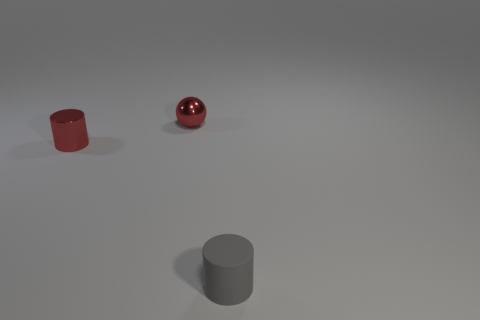Are there any tiny cylinders of the same color as the small sphere?
Offer a very short reply. Yes. What shape is the metallic thing that is the same color as the metal cylinder?
Make the answer very short. Sphere. Is there any other thing that has the same color as the small sphere?
Your answer should be very brief. Yes. What is the material of the small thing that is right of the red shiny cylinder and in front of the tiny red metallic sphere?
Your answer should be very brief. Rubber. How many small cylinders are the same color as the small metallic ball?
Offer a very short reply. 1. There is a tiny metal sphere; is its color the same as the cylinder left of the small rubber cylinder?
Ensure brevity in your answer.  Yes. The other object that is the same shape as the rubber thing is what size?
Your answer should be compact. Small. Are there any other things that are the same shape as the gray thing?
Give a very brief answer. Yes. Is the color of the small ball the same as the tiny metallic cylinder?
Ensure brevity in your answer.  Yes. How many things are tiny red shiny spheres that are left of the small matte cylinder or small gray objects?
Make the answer very short. 2. 